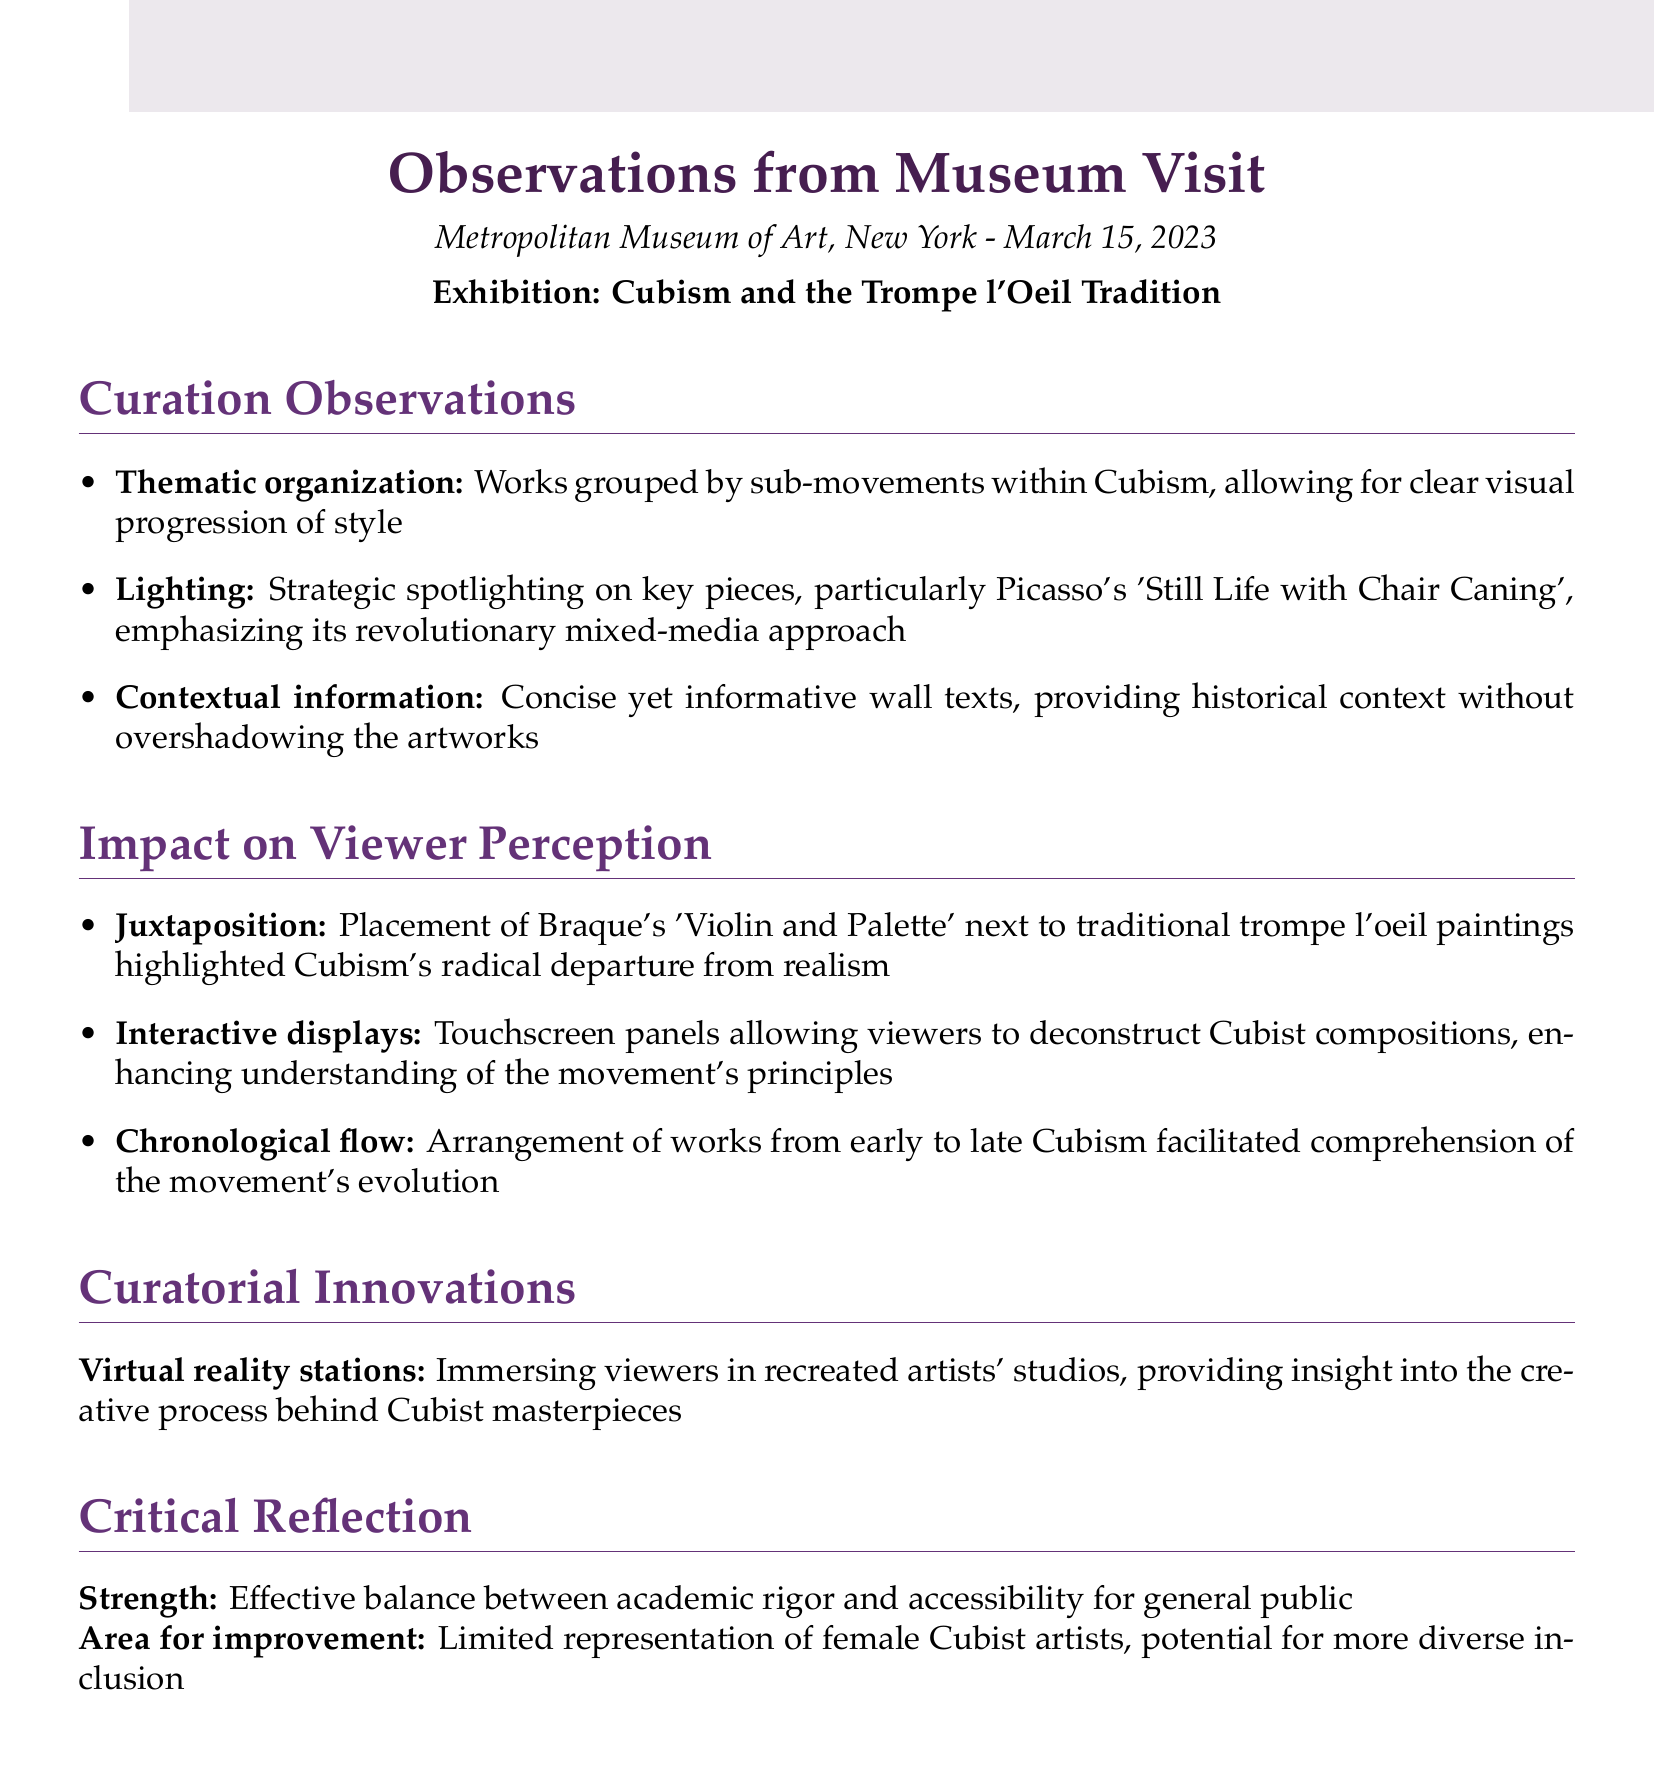What is the name of the exhibition? The name of the exhibition is provided in the document under 'Exhibition:', which states "Cubism and the Trompe l'Oeil Tradition."
Answer: Cubism and the Trompe l'Oeil Tradition What date was the museum visit? The date of the museum visit is mentioned at the beginning of the document, which states "March 15, 2023."
Answer: March 15, 2023 Which artist's work was spotlighted for its mixed-media approach? The work that was spotlighted is specified, stating it is Picasso's 'Still Life with Chair Caning.'
Answer: Picasso's 'Still Life with Chair Caning' What is one method used to enhance viewer understanding of Cubism? The document mentions "Touchscreen panels allowing viewers to deconstruct Cubist compositions" as a method.
Answer: Touchscreen panels How does the arrangement of works facilitate comprehension? The document states that the "Arrangement of works from early to late Cubism facilitated comprehension."
Answer: Early to late Cubism What is a strength of the exhibition according to the critical reflection? The strength mentioned is an "Effective balance between academic rigor and accessibility for general public."
Answer: Effective balance What was an area for improvement noted in the document? The area for improvement highlighted is "Limited representation of female Cubist artists."
Answer: Limited representation of female Cubist artists What innovative technique is mentioned in the curation? The curation innovation discussed is "Virtual reality stations."
Answer: Virtual reality stations 